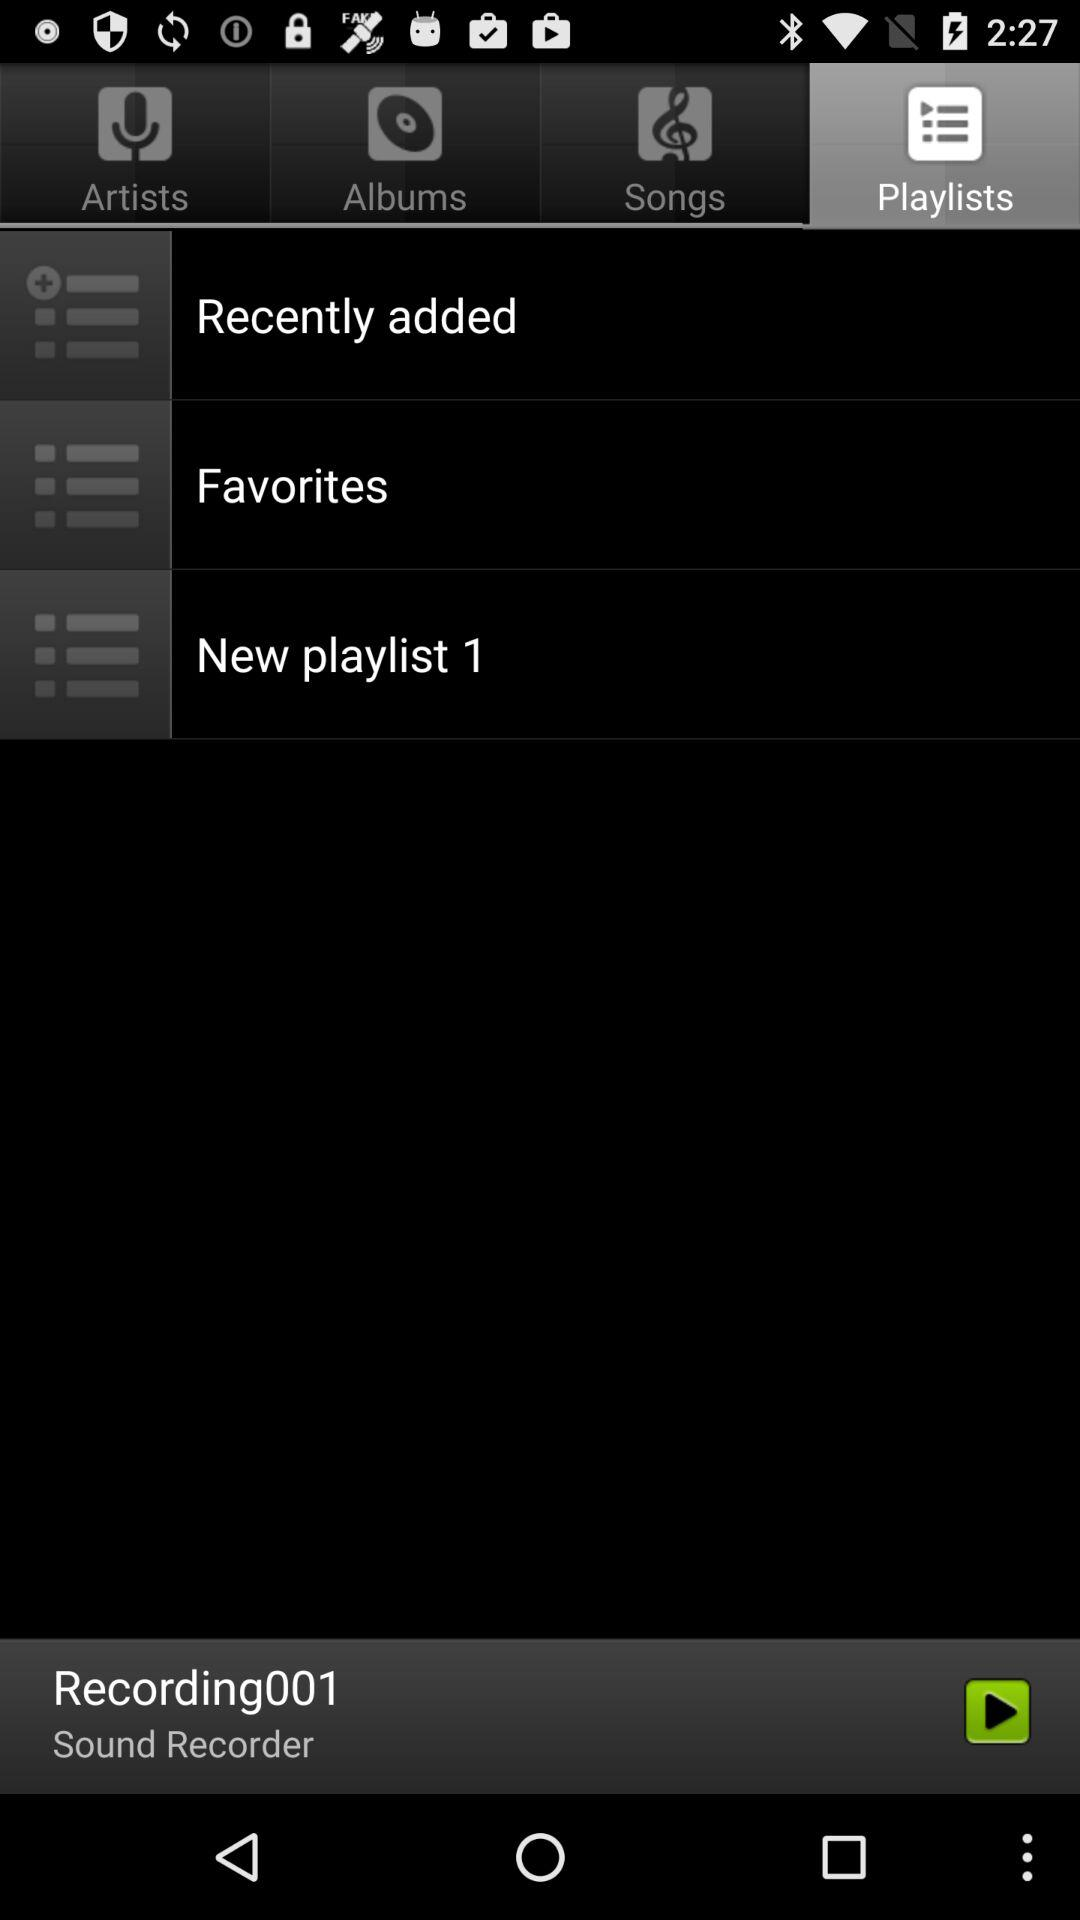Which tab is selected right now? Right now, the selected tab is "Playlists". 